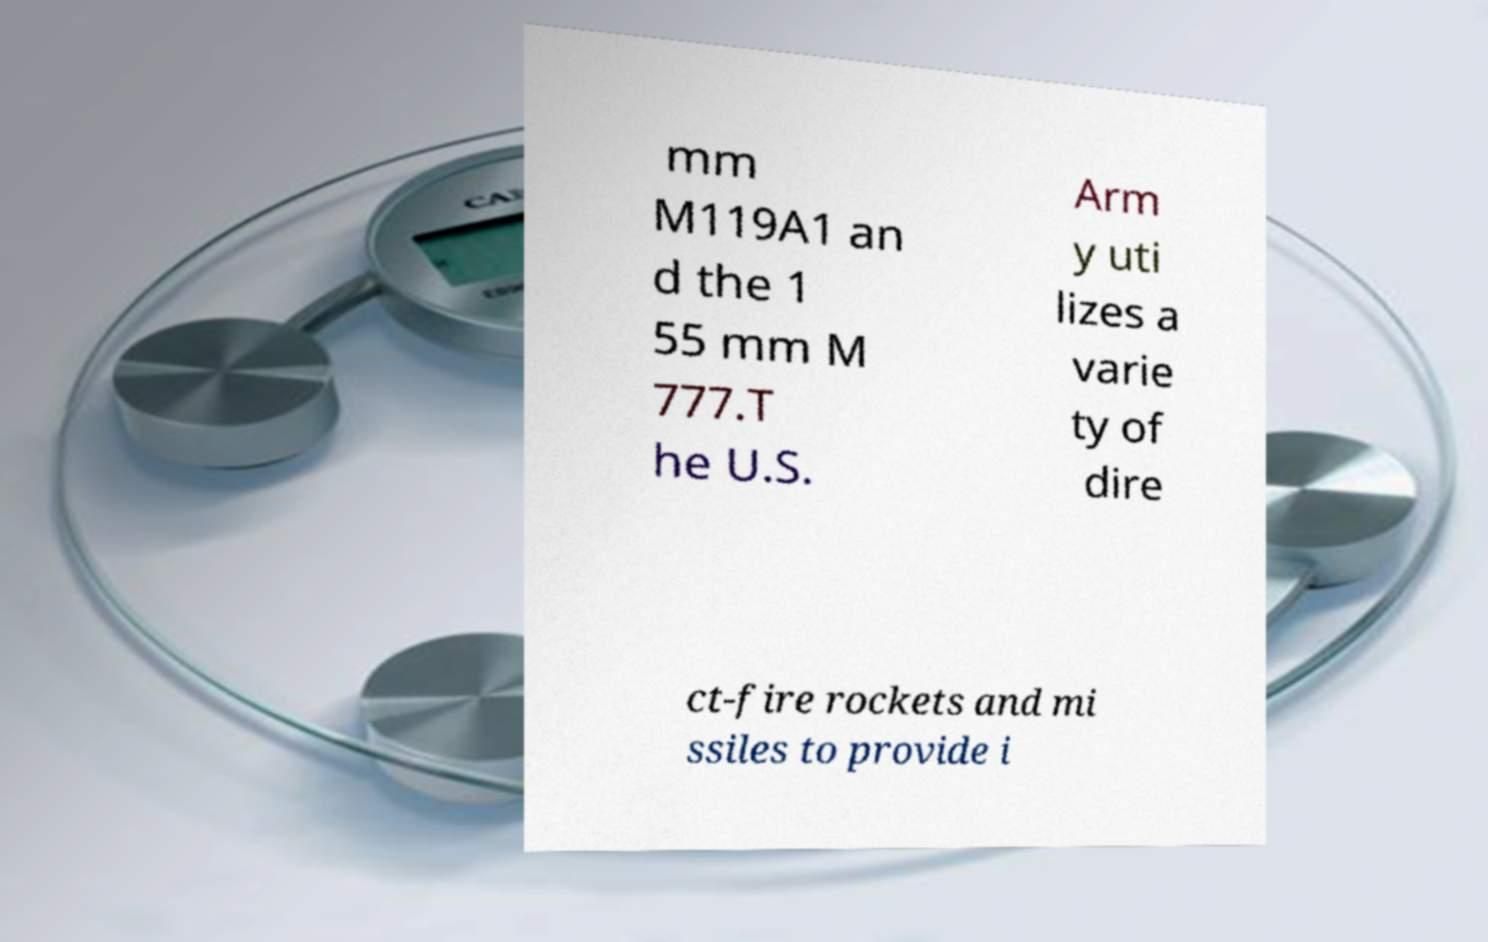I need the written content from this picture converted into text. Can you do that? mm M119A1 an d the 1 55 mm M 777.T he U.S. Arm y uti lizes a varie ty of dire ct-fire rockets and mi ssiles to provide i 